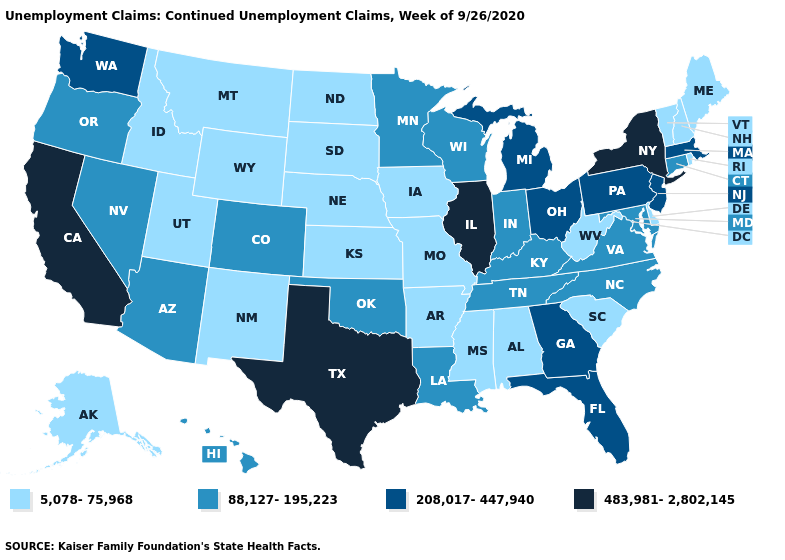What is the value of Texas?
Answer briefly. 483,981-2,802,145. Among the states that border Michigan , which have the highest value?
Concise answer only. Ohio. Does the first symbol in the legend represent the smallest category?
Short answer required. Yes. What is the lowest value in states that border Missouri?
Write a very short answer. 5,078-75,968. Which states have the lowest value in the USA?
Answer briefly. Alabama, Alaska, Arkansas, Delaware, Idaho, Iowa, Kansas, Maine, Mississippi, Missouri, Montana, Nebraska, New Hampshire, New Mexico, North Dakota, Rhode Island, South Carolina, South Dakota, Utah, Vermont, West Virginia, Wyoming. Does Illinois have the highest value in the MidWest?
Concise answer only. Yes. What is the value of Massachusetts?
Write a very short answer. 208,017-447,940. What is the highest value in the USA?
Keep it brief. 483,981-2,802,145. What is the lowest value in the USA?
Quick response, please. 5,078-75,968. Name the states that have a value in the range 88,127-195,223?
Keep it brief. Arizona, Colorado, Connecticut, Hawaii, Indiana, Kentucky, Louisiana, Maryland, Minnesota, Nevada, North Carolina, Oklahoma, Oregon, Tennessee, Virginia, Wisconsin. What is the value of Oregon?
Keep it brief. 88,127-195,223. Name the states that have a value in the range 5,078-75,968?
Write a very short answer. Alabama, Alaska, Arkansas, Delaware, Idaho, Iowa, Kansas, Maine, Mississippi, Missouri, Montana, Nebraska, New Hampshire, New Mexico, North Dakota, Rhode Island, South Carolina, South Dakota, Utah, Vermont, West Virginia, Wyoming. What is the value of Virginia?
Be succinct. 88,127-195,223. Does Maryland have a higher value than Virginia?
Be succinct. No. Does Virginia have the same value as Maine?
Answer briefly. No. 